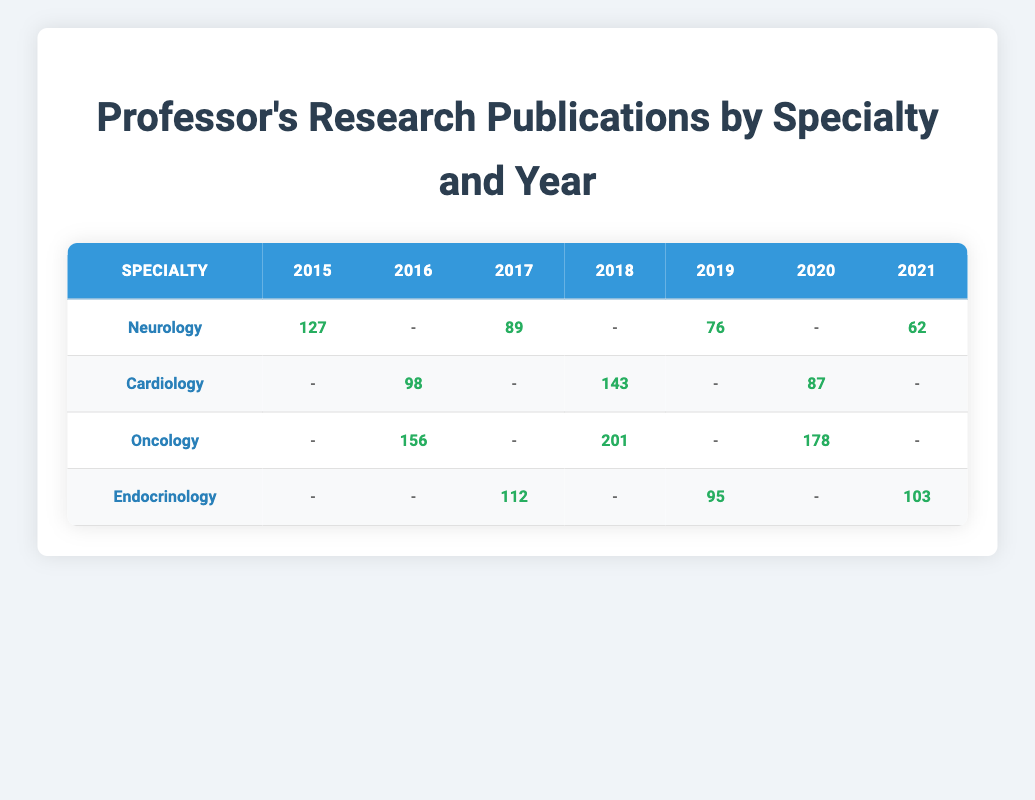What is the highest number of citations in a single year for Neurology? The highest number of citations for Neurology is from 2015 with 127 citations. This is found by looking through the Neurology row and identifying the maximum value.
Answer: 127 Which specialty had the most publications in 2018? In 2018, Oncology had the most citations (201) compared to other specialties. Looking at the table for the year 2018, Oncology has the highest citation count.
Answer: Oncology How many total citations did Endocrinology have from 2017 to 2021? To find the total citations for Endocrinology from 2017 to 2021, we look at the citations for each year: 112 (2017) + 95 (2019) + 103 (2021) = 310. We do not include 2018 because there is no entry for that year.
Answer: 310 Did Cardiology publish any papers in 2015? No, Cardiology did not have any publications in 2015, as indicated by the '-' in the 2015 column for Cardiology.
Answer: No What is the average number of citations for Oncology in the years they published? Oncology had publications in 2016 (156), 2018 (201), and 2020 (178). To find the average, we calculate (156 + 201 + 178) / 3 = 178.33. Dividing by the number of publication years (3) gives us the result.
Answer: 178.33 Which year saw the least number of citations in Neurology? The least number of citations in Neurology is 62, published in 2021. The values for each year under Neurology are checked to find the minimum.
Answer: 62 Did all specialties publish in every year? No, not all specialties published in every year, as seen in the table. For example, Cardiology did not have publications in 2015 and 2019.
Answer: No In which year did Endocrinology have its highest citations? Endocrinology had its highest citations in 2017 with 112. Comparing the citations listed for each year shows that 112 is the highest citation for that specialty.
Answer: 112 